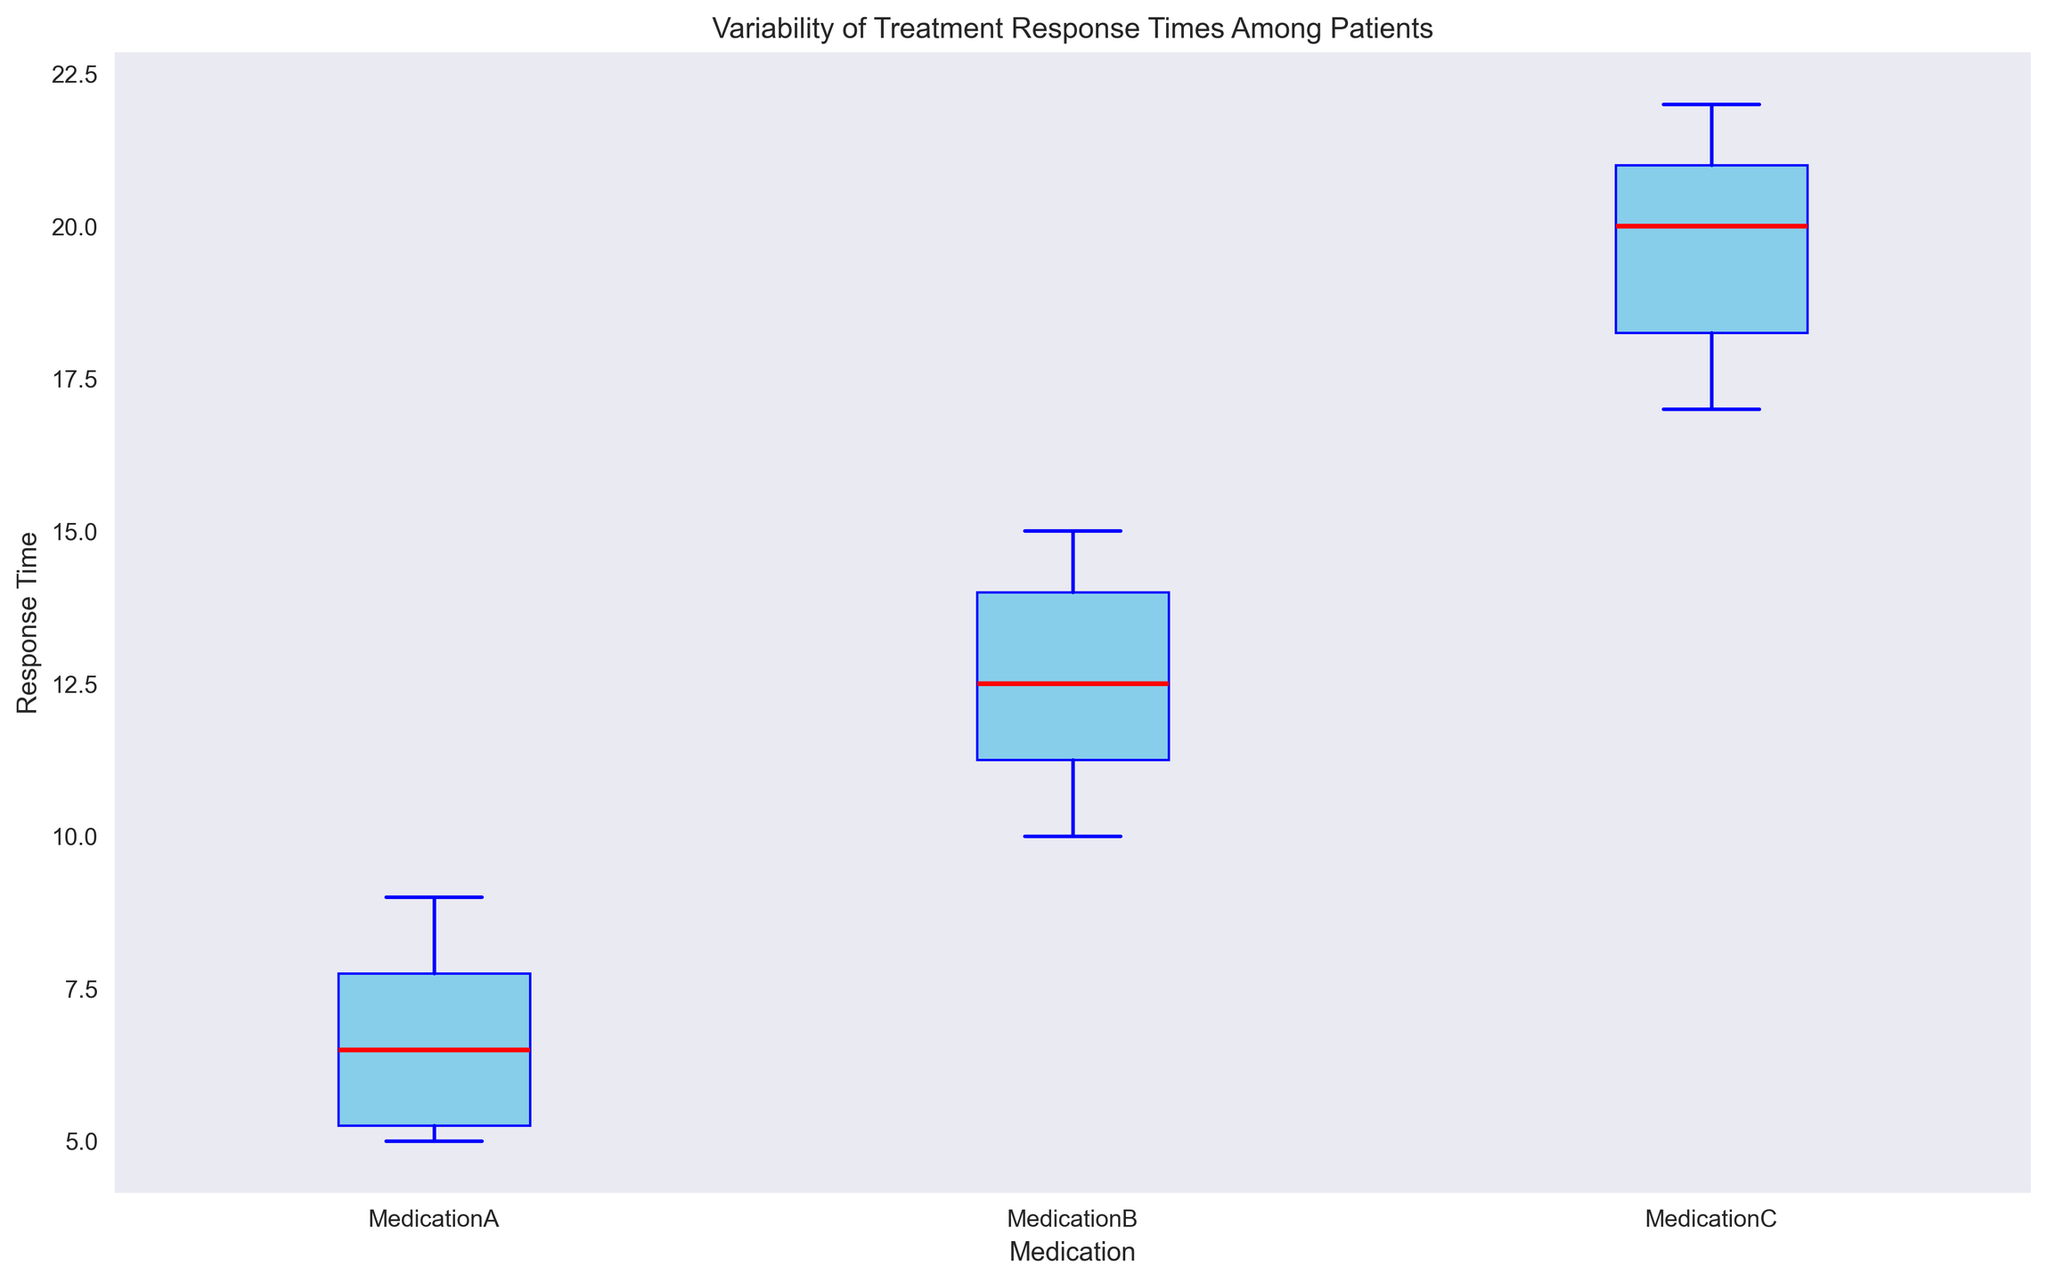What's the median response time for Medication A? To find the median response time for Medication A, locate the red line within the box representing Medication A on the plot. This line indicates the median value.
Answer: 6.5 Which medication has the highest median response time? Compare the heights of the red lines (medians) within the boxes for each medication. The highest red line corresponds to the highest median response time.
Answer: Medication C Is there more variability in response times for Medication B or Medication C? Assess the length (height) of the boxes and whiskers for both medications. Longer boxes and whiskers indicate greater variability.
Answer: Medication B What's the range of response times for Medication B? The range is found by subtracting the smallest value (lower whisker) from the largest value (upper whisker) for Medication B.
Answer: 5 (15 - 10) Which medication has the smallest interquartile range (IQR)? The IQR is indicated by the height of the box (distance between the lower and upper quartiles). The smallest box corresponds to the smallest IQR.
Answer: Medication A Are there any outliers in the data? Outliers are typically shown as points outside the whiskers of the box plot. Look for any isolated points beyond the whiskers.
Answer: No Between Medication A and Medication B, which one has the lowest median response time? Compare the heights of the red lines within the boxes for Medication A and Medication B. The lower red line indicates the lower median response time.
Answer: Medication A How does the median response time of Medication C compare to Medication A? Look at the red lines (medians) within the boxes for both medications and compare their heights.
Answer: Medication C is higher What can you infer about the consistency of treatment response times among patients using Medication A? Consistency can be inferred by the size of the box and whiskers. Smaller boxes and whiskers indicate more consistent response times. Since Medication A has the smallest box and whiskers, its response times are more consistent.
Answer: Consistent What's the difference in the median response times between Medication A and Medication C? Find the medians (red lines) for both medications. Take the difference between these two values.
Answer: 13.5 (20 - 6.5) 